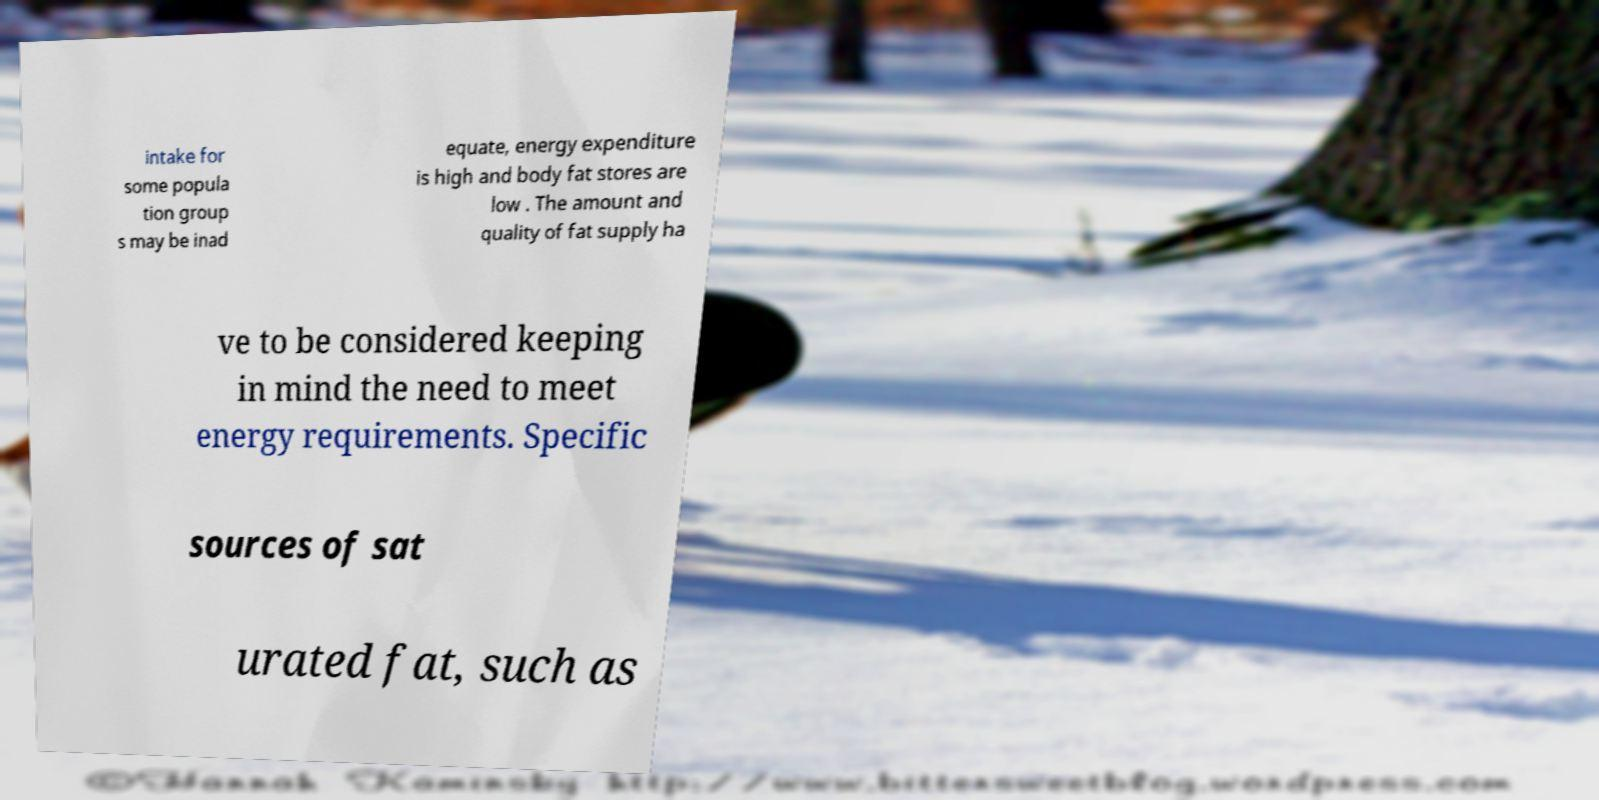Please read and relay the text visible in this image. What does it say? intake for some popula tion group s may be inad equate, energy expenditure is high and body fat stores are low . The amount and quality of fat supply ha ve to be considered keeping in mind the need to meet energy requirements. Specific sources of sat urated fat, such as 